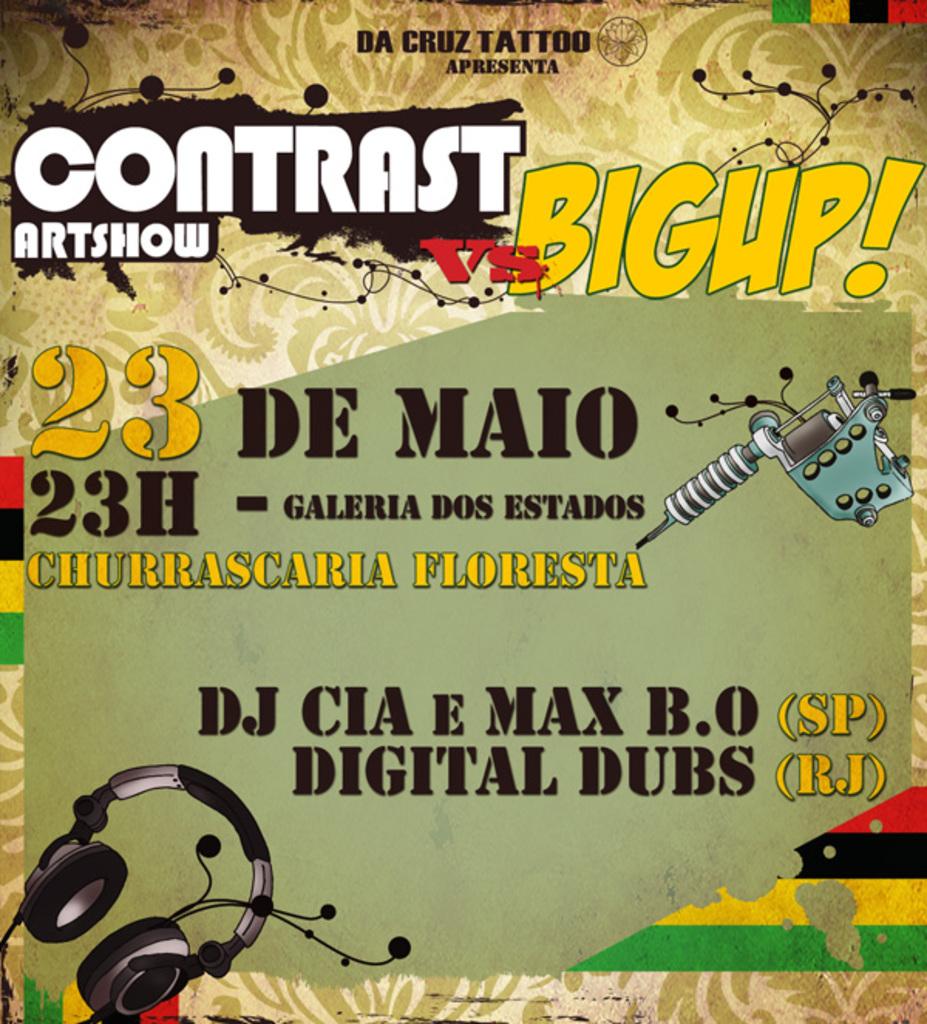What is the name of the art show?
Make the answer very short. Contrast. Are the dubs digital?
Your answer should be compact. Yes. 